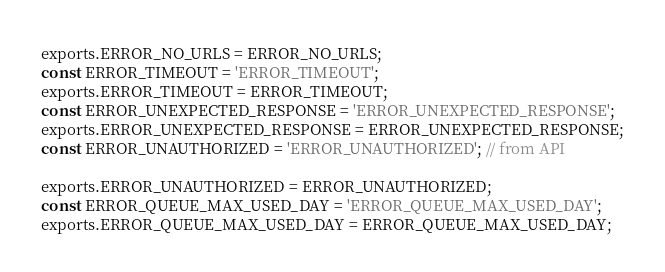<code> <loc_0><loc_0><loc_500><loc_500><_JavaScript_>exports.ERROR_NO_URLS = ERROR_NO_URLS;
const ERROR_TIMEOUT = 'ERROR_TIMEOUT';
exports.ERROR_TIMEOUT = ERROR_TIMEOUT;
const ERROR_UNEXPECTED_RESPONSE = 'ERROR_UNEXPECTED_RESPONSE';
exports.ERROR_UNEXPECTED_RESPONSE = ERROR_UNEXPECTED_RESPONSE;
const ERROR_UNAUTHORIZED = 'ERROR_UNAUTHORIZED'; // from API

exports.ERROR_UNAUTHORIZED = ERROR_UNAUTHORIZED;
const ERROR_QUEUE_MAX_USED_DAY = 'ERROR_QUEUE_MAX_USED_DAY';
exports.ERROR_QUEUE_MAX_USED_DAY = ERROR_QUEUE_MAX_USED_DAY;</code> 